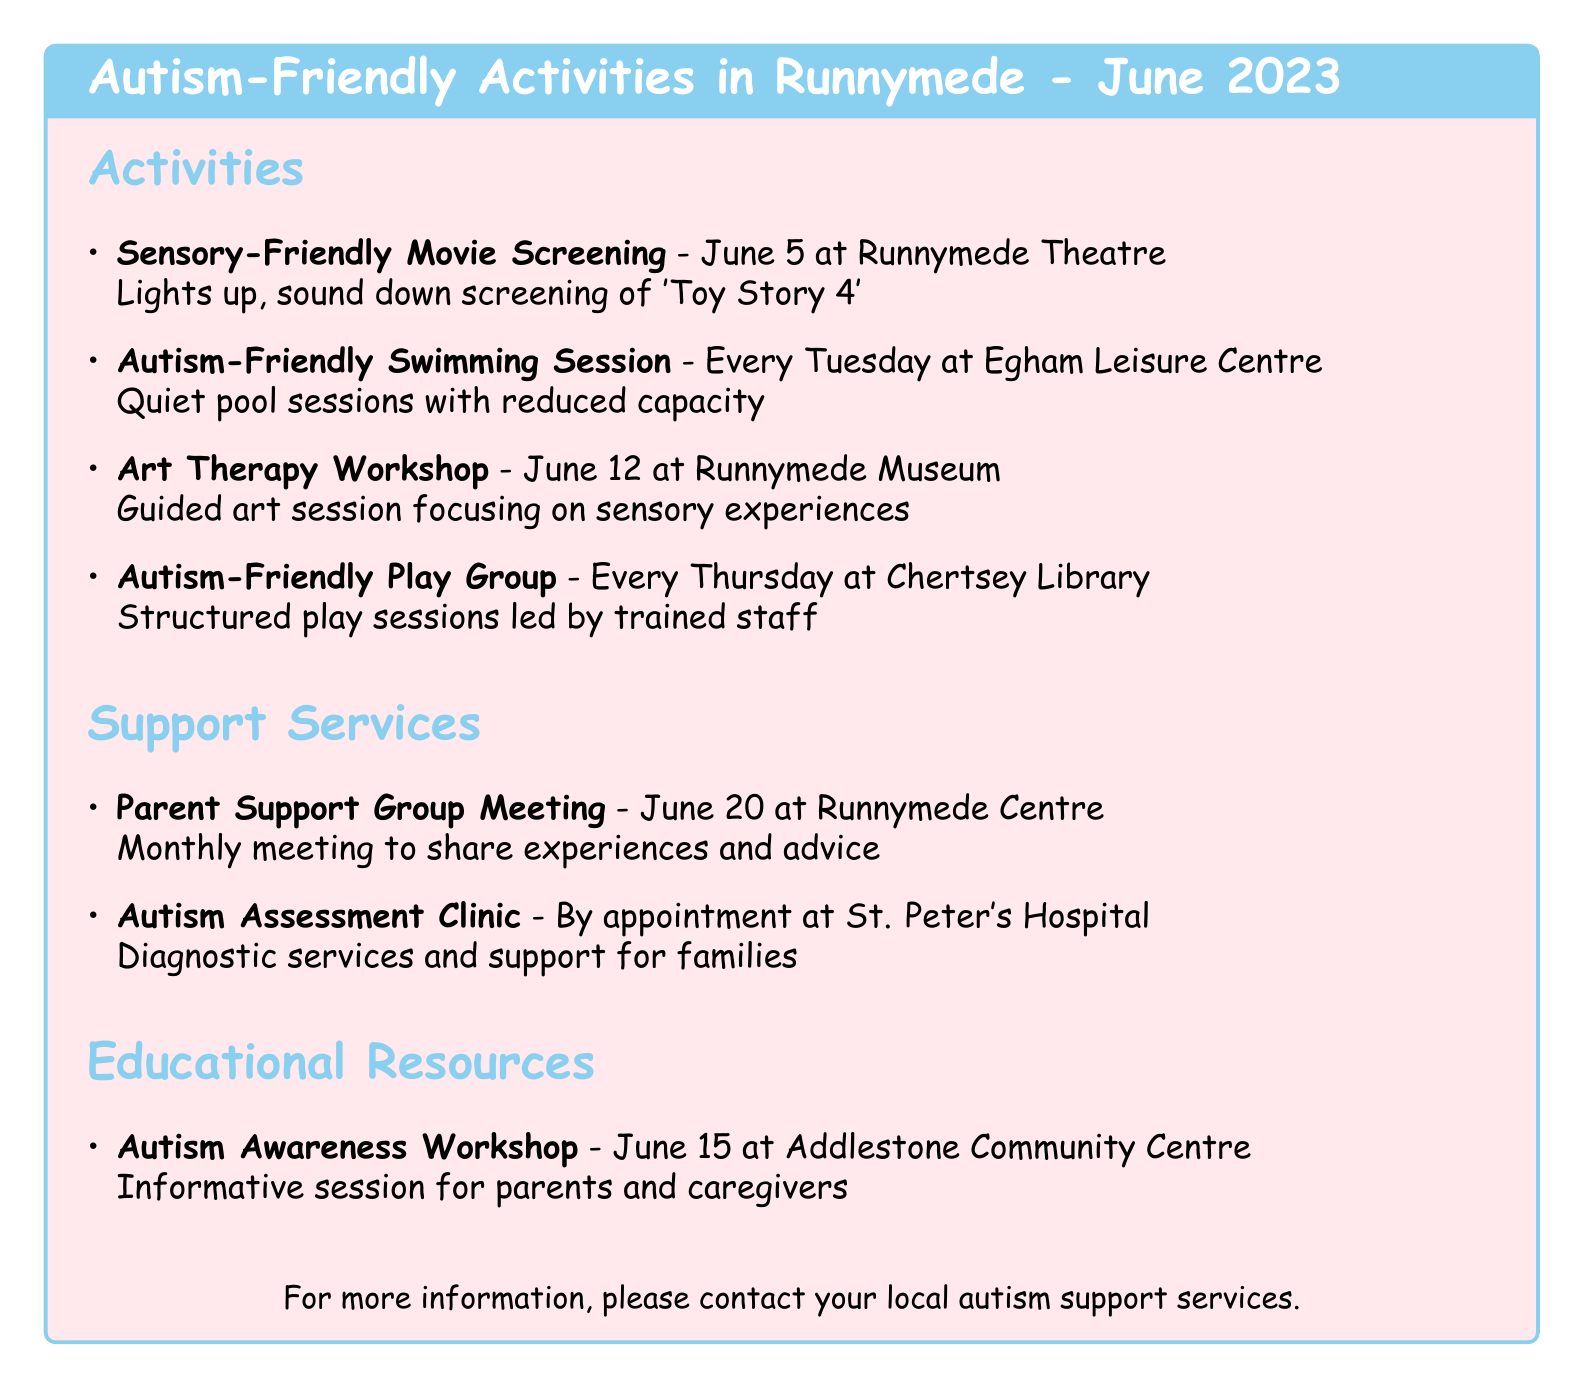what is the location of the Art Therapy Workshop? The document lists Runnymede Museum as the location for the Art Therapy Workshop.
Answer: Runnymede Museum when is the Autism-Friendly Swimming Session scheduled? The document states that the Autism-Friendly Swimming Session occurs every Tuesday in June.
Answer: Every Tuesday in June which movie is being screened in the Sensory-Friendly Movie Screening? The document specifies that 'Toy Story 4' is the movie being screened.
Answer: Toy Story 4 how often does the Parent Support Group Meeting occur? The document indicates that the Parent Support Group Meeting is a monthly meeting.
Answer: Monthly what type of session is the Autism Awareness Workshop classified as? The document describes the Autism Awareness Workshop as an informative session.
Answer: Informative session where is the Autism Assessment Clinic held? According to the document, the Autism Assessment Clinic is held at St. Peter's Hospital.
Answer: St. Peter's Hospital which library hosts the Autism-Friendly Play Group? The document identifies Chertsey Library as the host of the Autism-Friendly Play Group.
Answer: Chertsey Library what is the date of the next Parent Support Group Meeting? The document states that the next Parent Support Group Meeting is on June 20, 2023.
Answer: June 20, 2023 